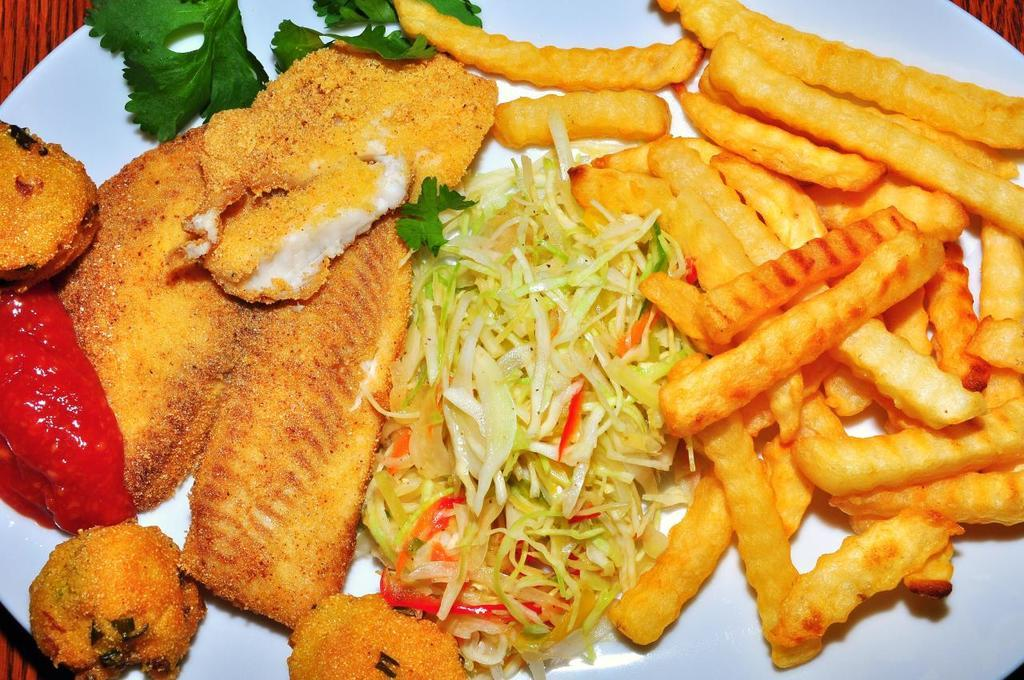What is on the plate that is visible in the image? There is a plate containing food in the image. What type of marble is used to decorate the son's room in the image? There is no mention of marble, a son, or a room in the image; it only features a plate containing food. 